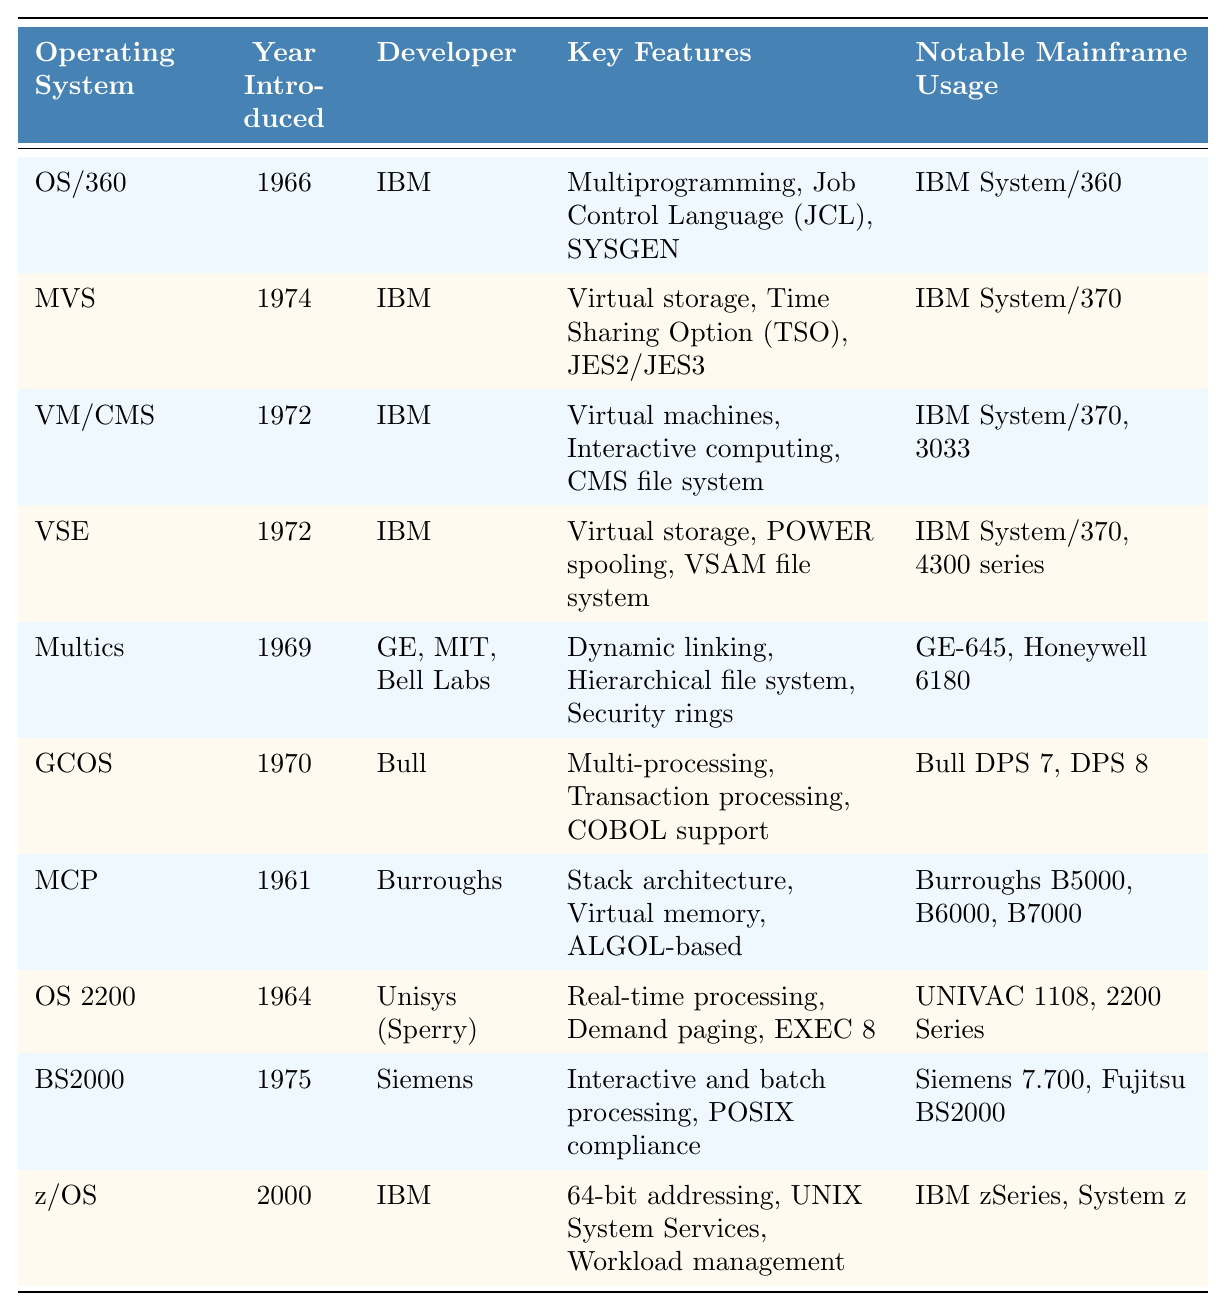What year was OS/360 introduced? The table lists "OS/360" under the "Operating System" column, and the corresponding year in the "Year Introduced" column is 1966.
Answer: 1966 Who developed MVS? Referring to the table, the "Developer" listed for "MVS" is "IBM."
Answer: IBM What are the key features of z/OS? To find the key features of "z/OS," look under the "Key Features" column, where it states "64-bit addressing, UNIX System Services, Workload management."
Answer: 64-bit addressing, UNIX System Services, Workload management Did Multics support virtual machines? Checking the "Key Features" for "Multics," it mentions "Dynamic linking, Hierarchical file system, Security rings," but does not list support for virtual machines. Thus, the answer is no.
Answer: No Which operating systems were introduced in the 1970s? By scanning the "Year Introduced" column, MVS (1974), VM/CMS (1972), VSE (1972), and BS2000 (1975) are all in the 1970s. Therefore, they are the operating systems that were introduced in that decade.
Answer: MVS, VM/CMS, VSE, BS2000 What is the notable mainframe usage for MCP? In the "Notable Mainframe Usage" column for "MCP," it lists "Burroughs B5000, B6000, B7000."
Answer: Burroughs B5000, B6000, B7000 Which operating system was the first to offer virtual storage? Looking at the "Key Features" for MVS, it states that it offers "Virtual storage," and since MVS was introduced in 1974, and VM/CMS was introduced earlier in 1972 but also included virtual machines, we can refer back to OS/360 as an early explanation. However, it was OS/360 that provided the groundwork for virtual storage. MVS later enhanced it significantly.
Answer: OS/360 List the operating systems developed by IBM. Going through the "Developer" column, I see that OS/360, MVS, VM/CMS, VSE, and z/OS were all developed by IBM.
Answer: OS/360, MVS, VM/CMS, VSE, z/OS Which operating system has the longest development period? MCP was introduced in 1961, and z/OS was introduced in 2000. Thus, by comparing the years each was introduced, MCP has the longest development trajectory leading up to z/OS in the last operating system.
Answer: MCP Which is the most recent operating system listed? The "Year Introduced" column shows the latest date is for z/OS, introduced in 2000, indicating it is the most recent operating system on the list.
Answer: z/OS What key feature differentiates BS2000 from the other systems? In the "Key Features" column, BS2000 is highlighted for its "POSIX compliance," which is a unique feature compared to other listed systems.
Answer: POSIX compliance 